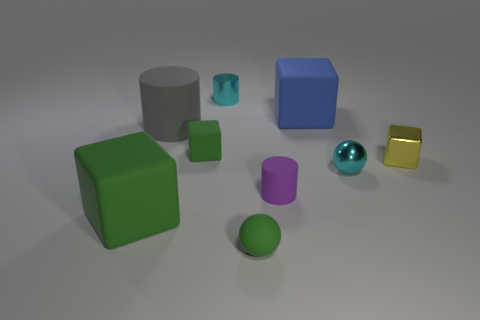Subtract all small cylinders. How many cylinders are left? 1 Subtract 2 cubes. How many cubes are left? 2 Subtract all yellow blocks. How many blocks are left? 3 Add 1 small yellow blocks. How many objects exist? 10 Subtract all brown cubes. Subtract all yellow cylinders. How many cubes are left? 4 Subtract all blocks. How many objects are left? 5 Subtract all small metal balls. Subtract all small matte things. How many objects are left? 5 Add 2 green rubber balls. How many green rubber balls are left? 3 Add 6 blue rubber objects. How many blue rubber objects exist? 7 Subtract 0 red cylinders. How many objects are left? 9 